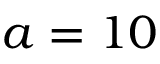<formula> <loc_0><loc_0><loc_500><loc_500>a = 1 0</formula> 